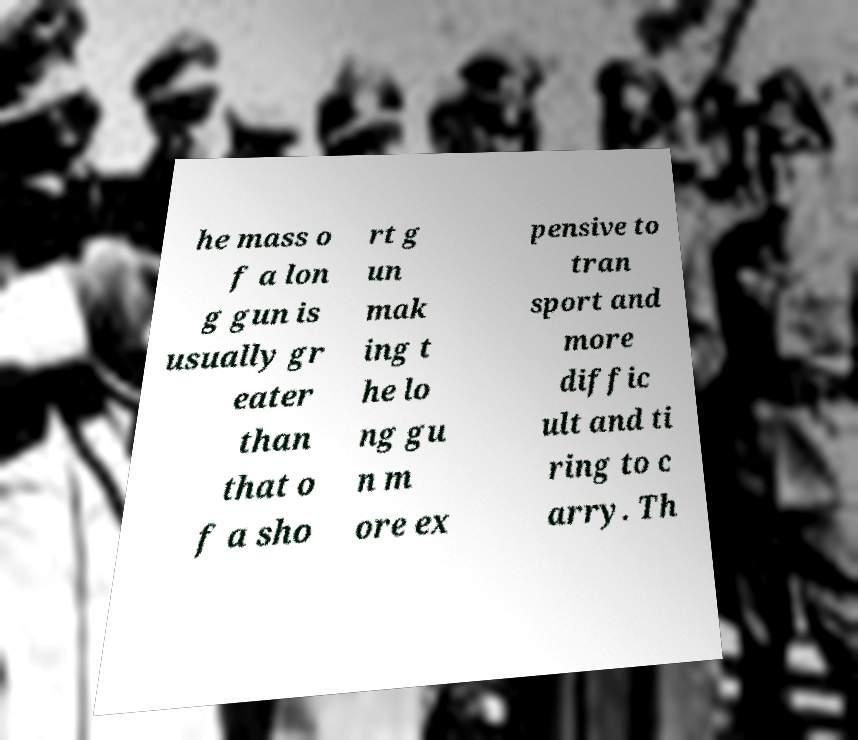Please identify and transcribe the text found in this image. he mass o f a lon g gun is usually gr eater than that o f a sho rt g un mak ing t he lo ng gu n m ore ex pensive to tran sport and more diffic ult and ti ring to c arry. Th 